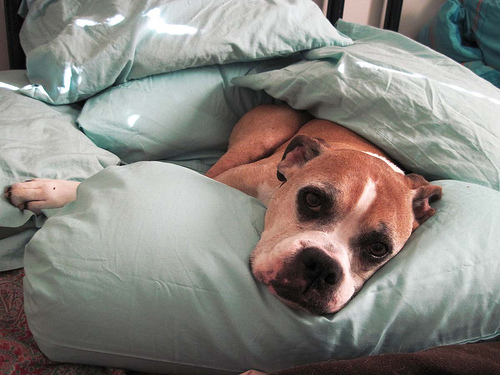<image>
Is there a dog next to the pillows? No. The dog is not positioned next to the pillows. They are located in different areas of the scene. 